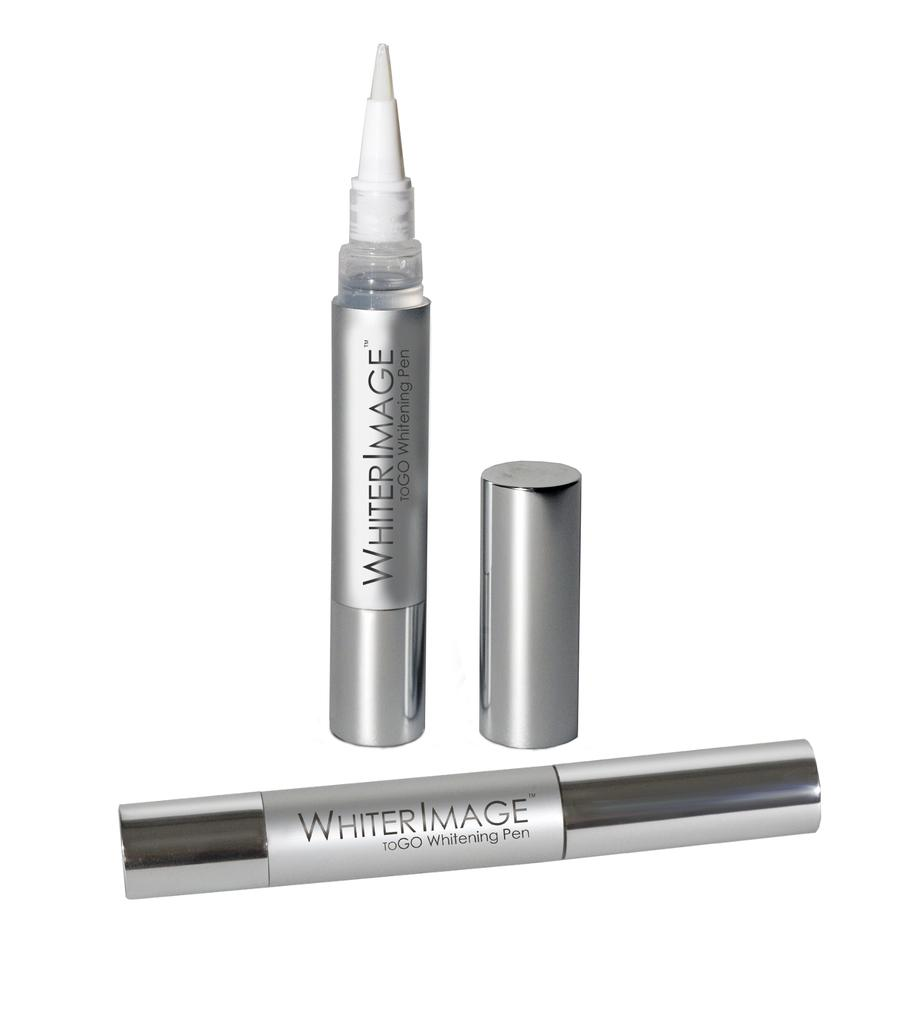<image>
Share a concise interpretation of the image provided. A pair of Whiter Image whitening pens, one is open. 